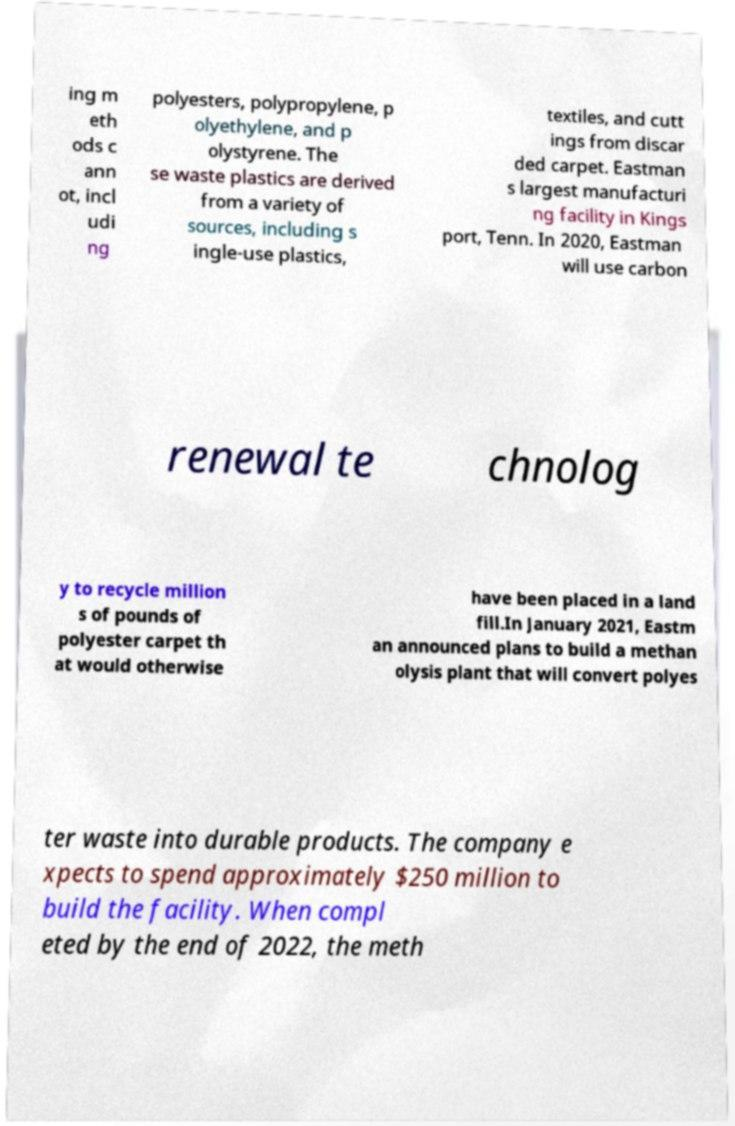I need the written content from this picture converted into text. Can you do that? ing m eth ods c ann ot, incl udi ng polyesters, polypropylene, p olyethylene, and p olystyrene. The se waste plastics are derived from a variety of sources, including s ingle-use plastics, textiles, and cutt ings from discar ded carpet. Eastman s largest manufacturi ng facility in Kings port, Tenn. In 2020, Eastman will use carbon renewal te chnolog y to recycle million s of pounds of polyester carpet th at would otherwise have been placed in a land fill.In January 2021, Eastm an announced plans to build a methan olysis plant that will convert polyes ter waste into durable products. The company e xpects to spend approximately $250 million to build the facility. When compl eted by the end of 2022, the meth 